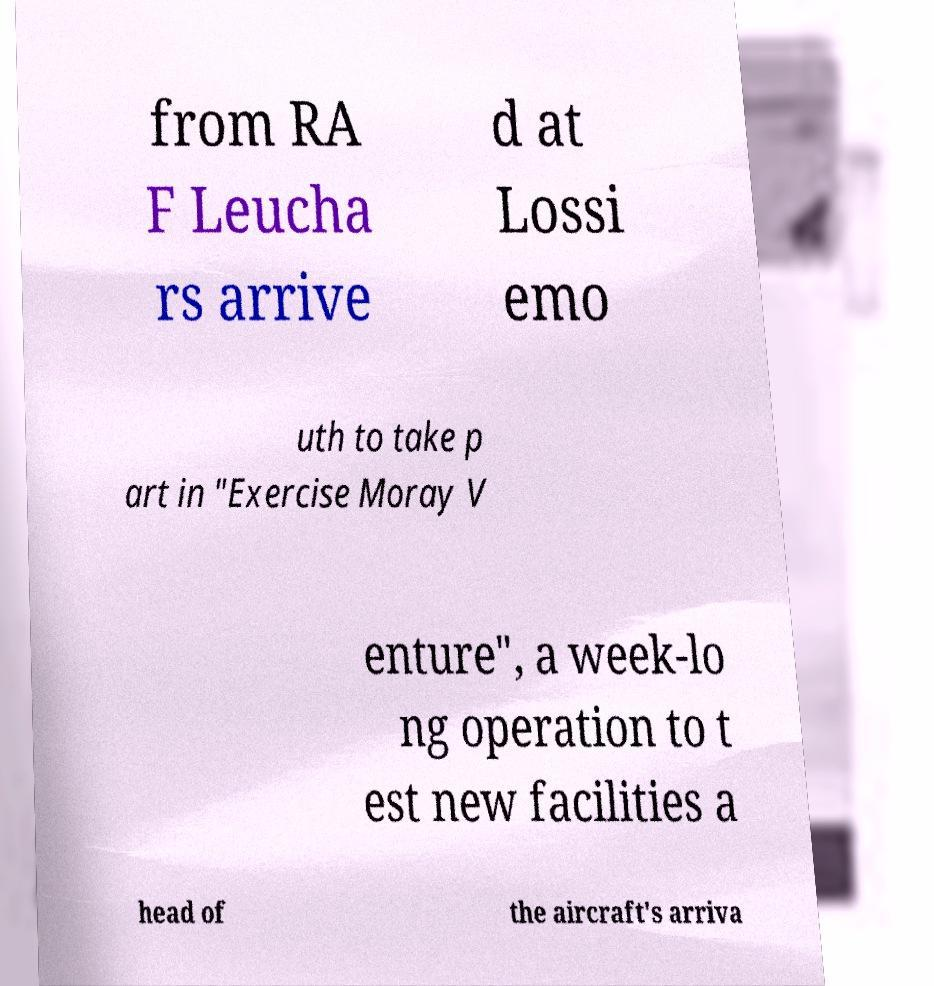Please identify and transcribe the text found in this image. from RA F Leucha rs arrive d at Lossi emo uth to take p art in "Exercise Moray V enture", a week-lo ng operation to t est new facilities a head of the aircraft's arriva 